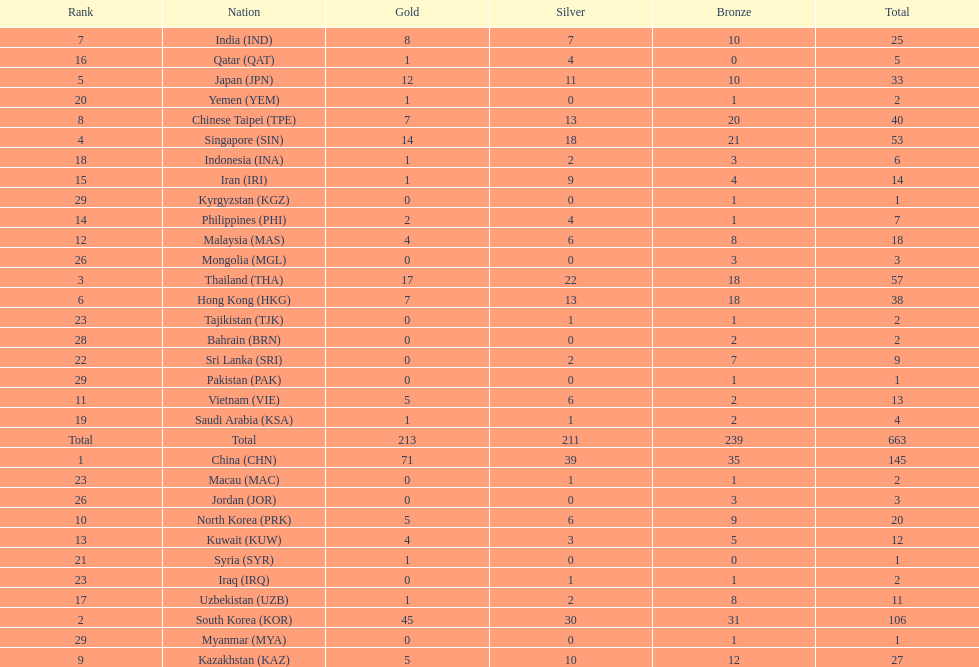What is the total number of medals that india won in the asian youth games? 25. 